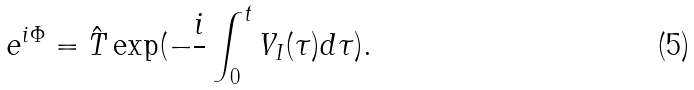<formula> <loc_0><loc_0><loc_500><loc_500>e ^ { i \Phi } = \hat { T } \exp ( - \frac { i } { } \int _ { 0 } ^ { t } V _ { I } ( \tau ) d \tau ) .</formula> 